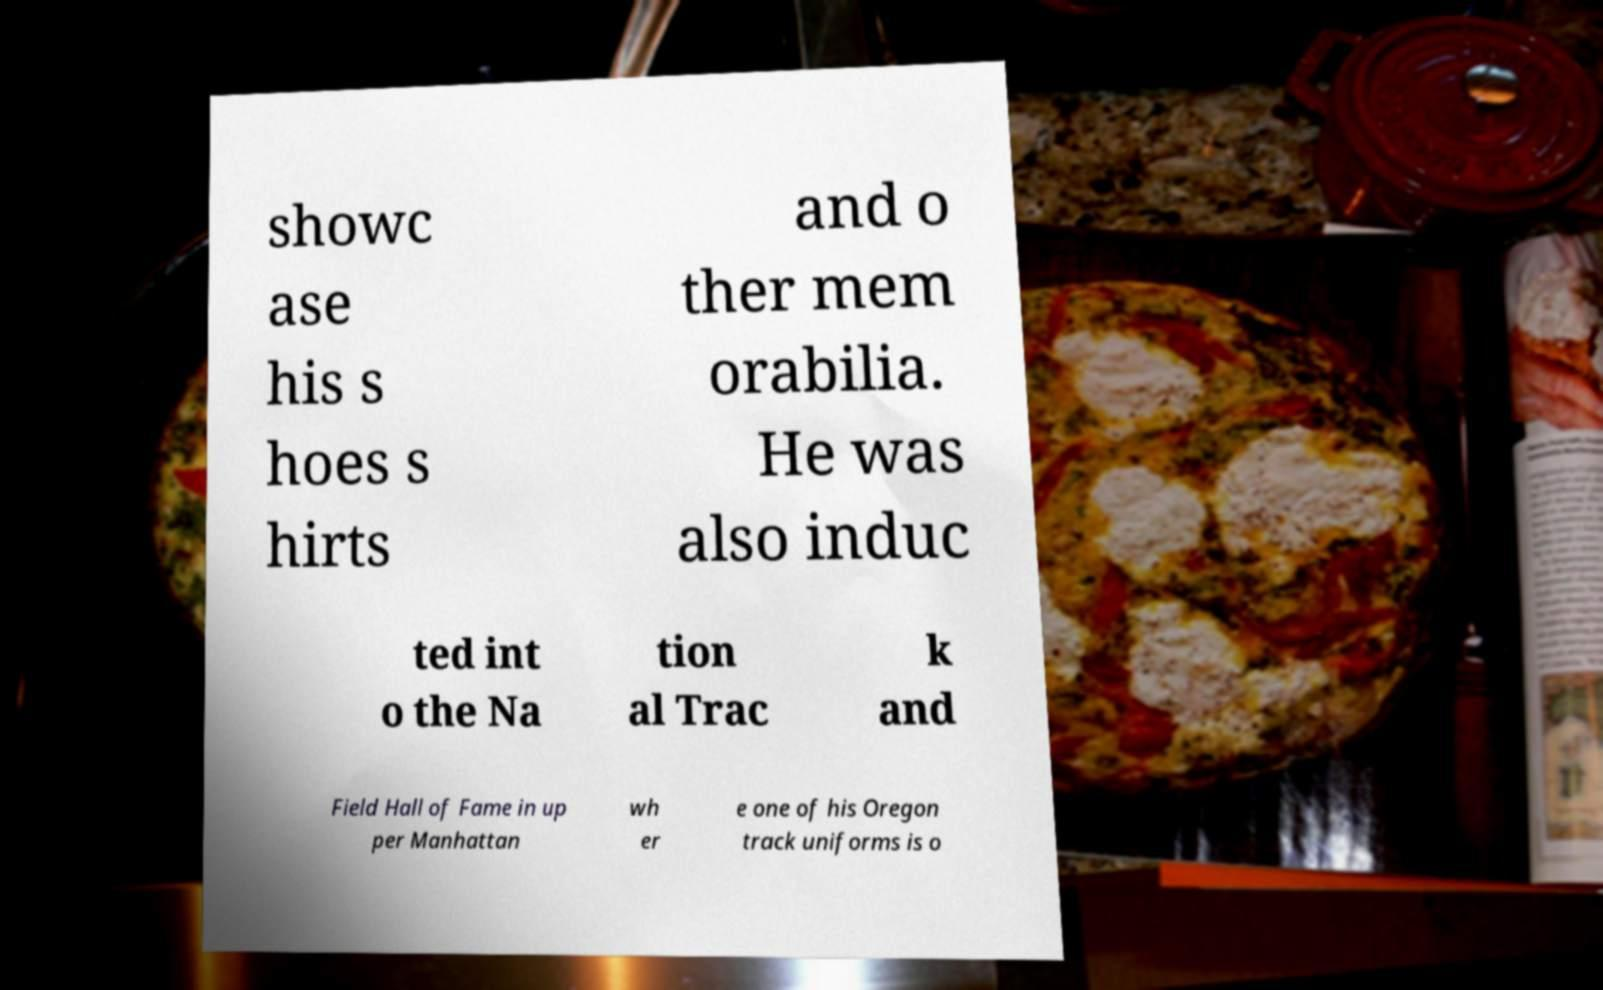For documentation purposes, I need the text within this image transcribed. Could you provide that? showc ase his s hoes s hirts and o ther mem orabilia. He was also induc ted int o the Na tion al Trac k and Field Hall of Fame in up per Manhattan wh er e one of his Oregon track uniforms is o 